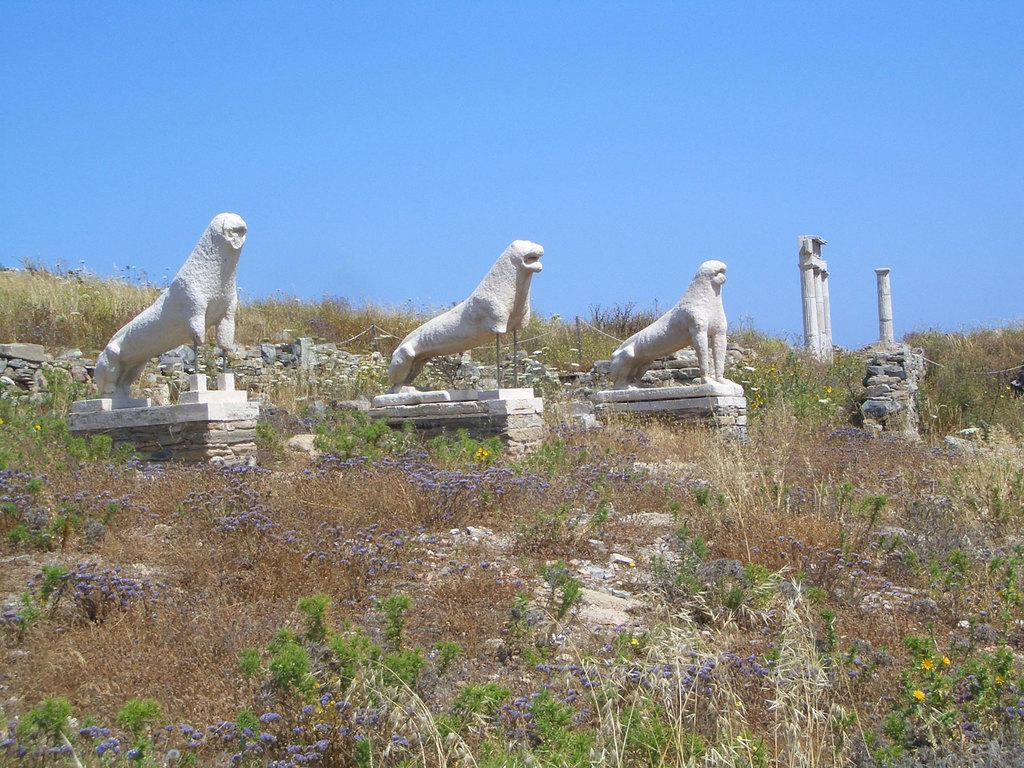What type of objects can be seen in the image? There are statues, poles, and rocks in the image. What is the surface on which these objects are placed? There is a ground visible in the image. Can you see a pig climbing the wall in the image? There is no pig or wall present in the image. 